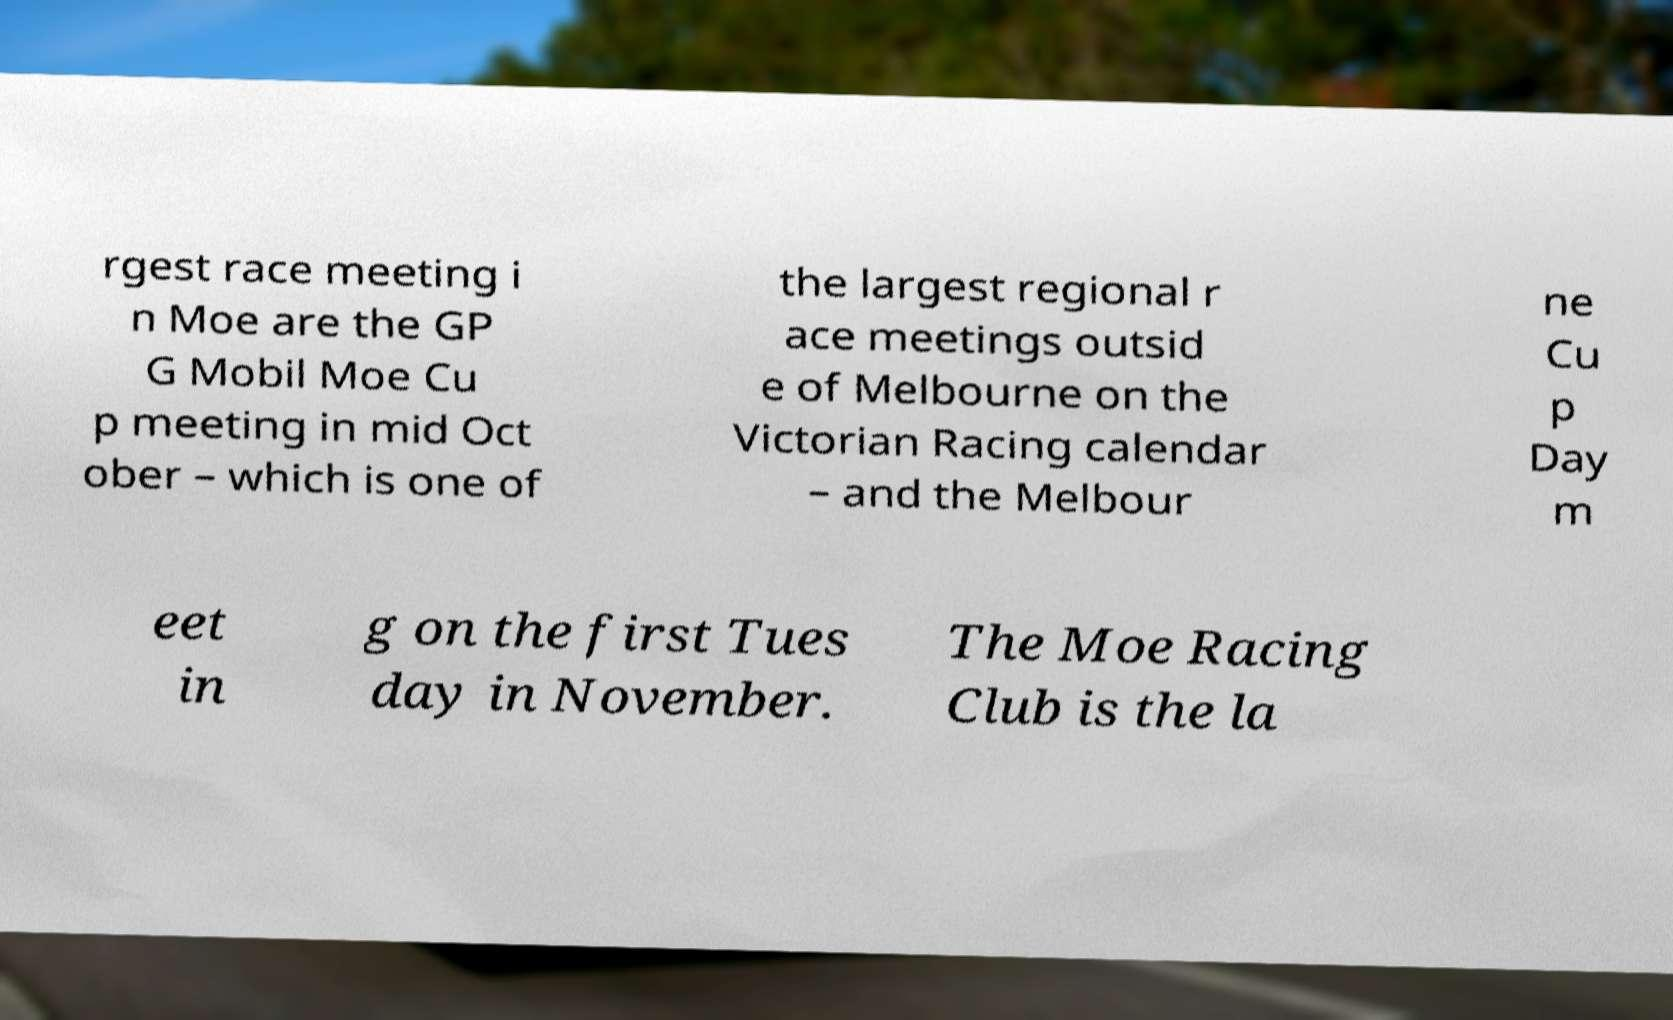Could you extract and type out the text from this image? rgest race meeting i n Moe are the GP G Mobil Moe Cu p meeting in mid Oct ober – which is one of the largest regional r ace meetings outsid e of Melbourne on the Victorian Racing calendar – and the Melbour ne Cu p Day m eet in g on the first Tues day in November. The Moe Racing Club is the la 